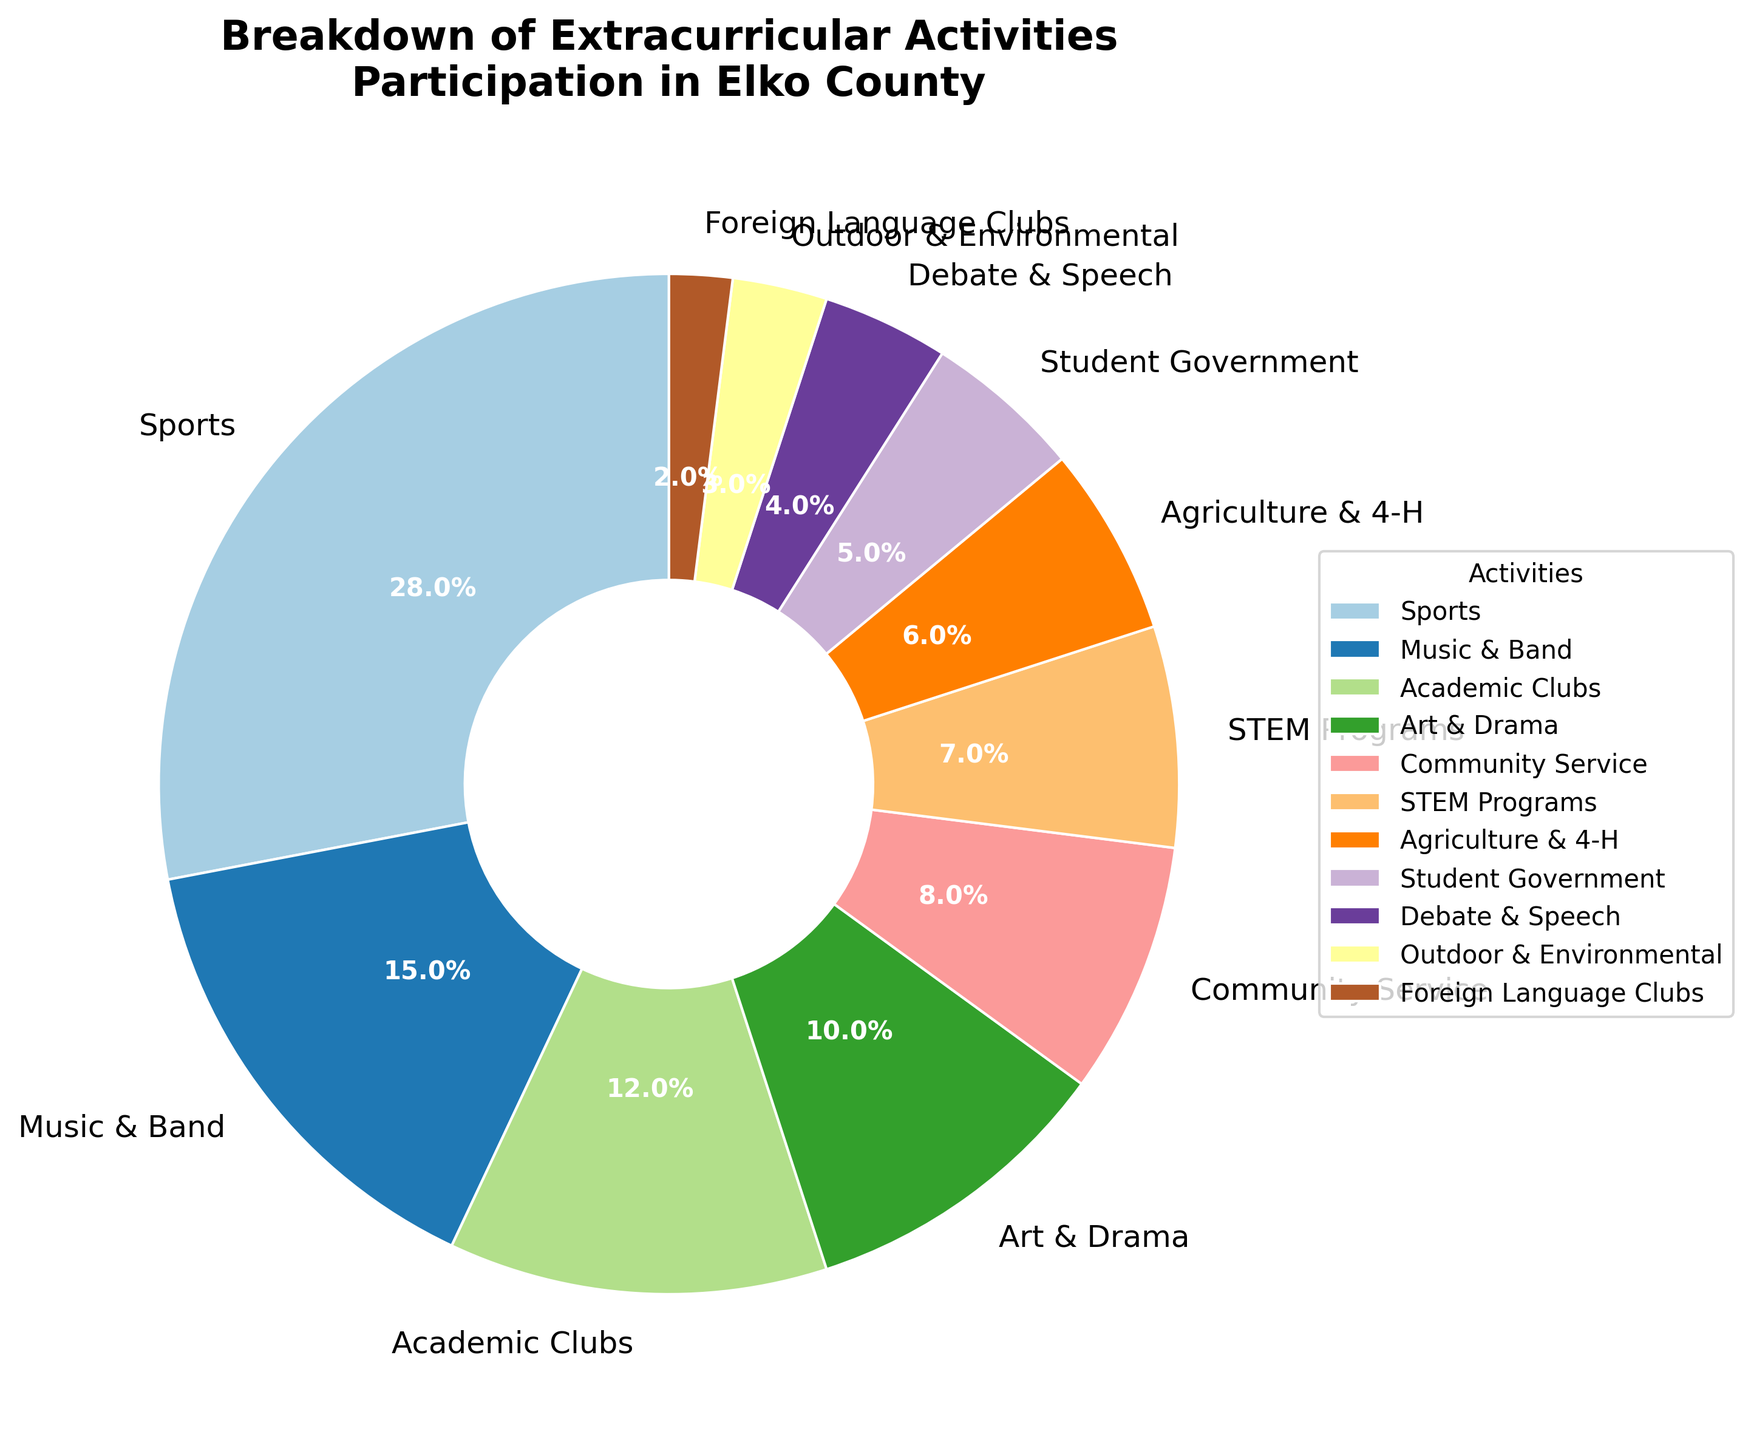Which activity has the highest participation percentage among Elko County students? The figure shows that "Sports" has the largest wedge in the pie chart.
Answer: Sports What percentage of students participate in Community Service and Agriculture & 4-H combined? The figure shows Community Service at 8% and Agriculture & 4-H at 6%. Adding these two percentages together: 8% + 6%, which is 14%.
Answer: 14% Is participation in STEM Programs higher than participation in Debate & Speech? The figure shows that STEM Programs have a wedge of 7% while Debate & Speech has a wedge of 4%. Since 7% is greater than 4%, participation in STEM Programs is higher than in Debate & Speech.
Answer: Yes Which activities have a participation percentage less than 5%? By observing the pie chart, the activities with wedges less than 5% are Student Government, Debate & Speech, Outdoor & Environmental, and Foreign Language Clubs.
Answer: Student Government, Debate & Speech, Outdoor & Environmental, Foreign Language Clubs What is the combined percentage of students participating in Music & Band, Academic Clubs, and Art & Drama? According to the figure, Music & Band is at 15%, Academic Clubs at 12%, and Art & Drama at 10%. Adding these together: 15% + 12% + 10% = 37%.
Answer: 37% How much less is the participation in Foreign Language Clubs compared to Sports? Sports participation is at 28% and Foreign Language Clubs at 2%. Subtracting these values: 28% - 2% = 26%.
Answer: 26% Which two activities have the closest participation percentages? By observing the pie chart, Community Service is at 8% and STEM Programs at 7%, and their difference is only 1%.
Answer: Community Service, STEM Programs What is the total percentage for activities with a percentage greater than or equal to 10%? The activities are Sports (28%), Music & Band (15%), Academic Clubs (12%), and Art & Drama (10%). Adding these together: 28% + 15% + 12% + 10% = 65%.
Answer: 65% Which activity has the smallest participation percentage? The figure shows that the smallest wedge is for "Foreign Language Clubs" at 2%.
Answer: Foreign Language Clubs 